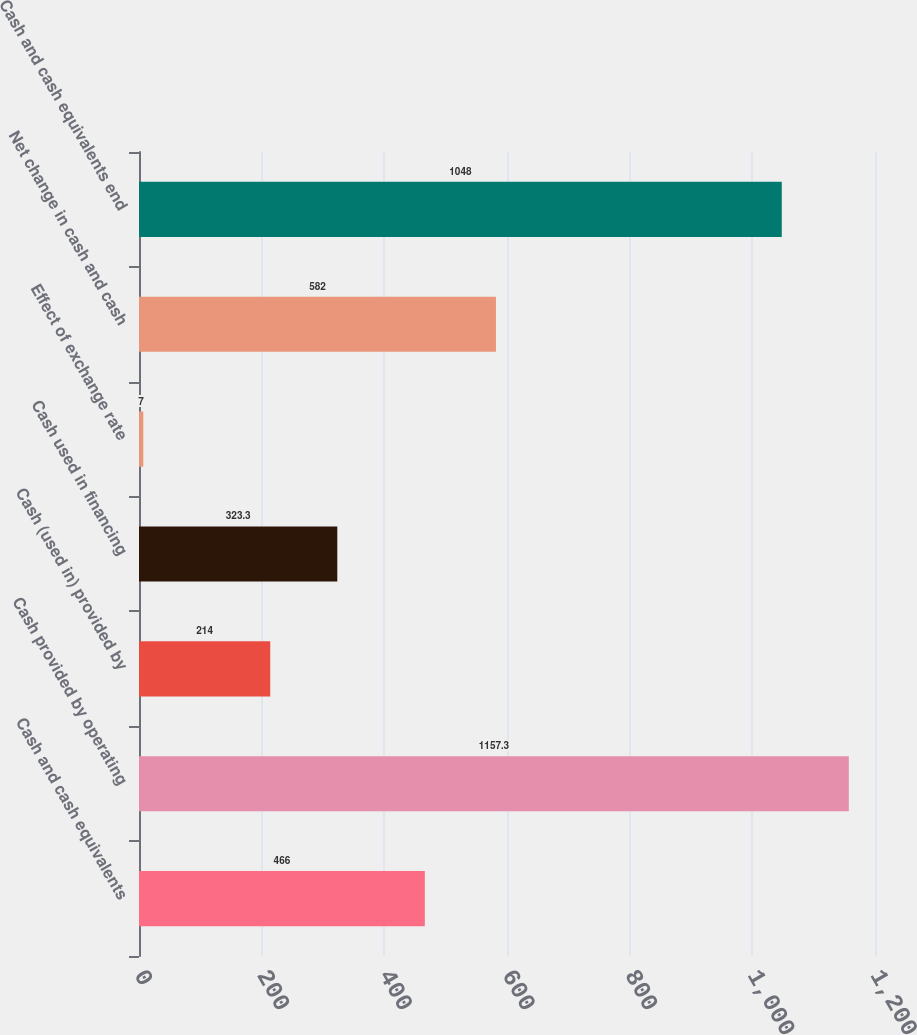<chart> <loc_0><loc_0><loc_500><loc_500><bar_chart><fcel>Cash and cash equivalents<fcel>Cash provided by operating<fcel>Cash (used in) provided by<fcel>Cash used in financing<fcel>Effect of exchange rate<fcel>Net change in cash and cash<fcel>Cash and cash equivalents end<nl><fcel>466<fcel>1157.3<fcel>214<fcel>323.3<fcel>7<fcel>582<fcel>1048<nl></chart> 